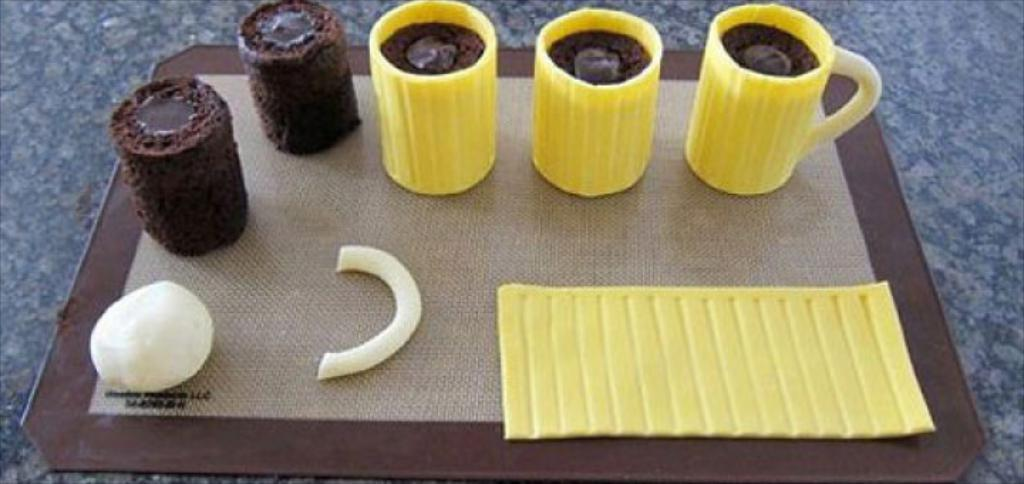What is present on the table in the image? There is a cup on the table in the image. Can you describe any other objects on the table? Unfortunately, the provided facts do not mention any other objects on the table. What type of glue is being used to attach the tooth to the advertisement in the image? There is no glue, tooth, or advertisement present in the image. 